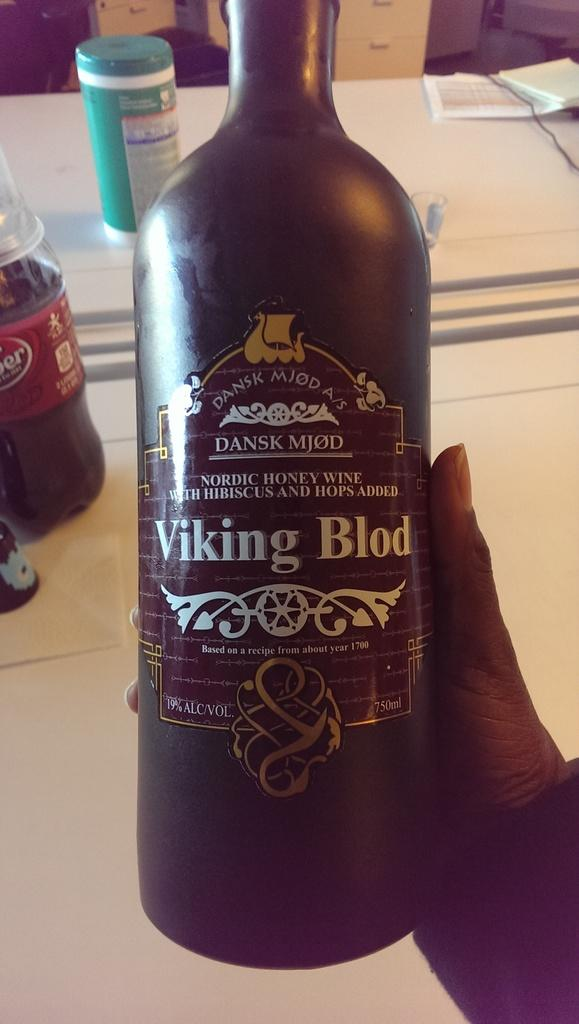<image>
Offer a succinct explanation of the picture presented. A bottle of Viking Blod is black and has white lettering. 